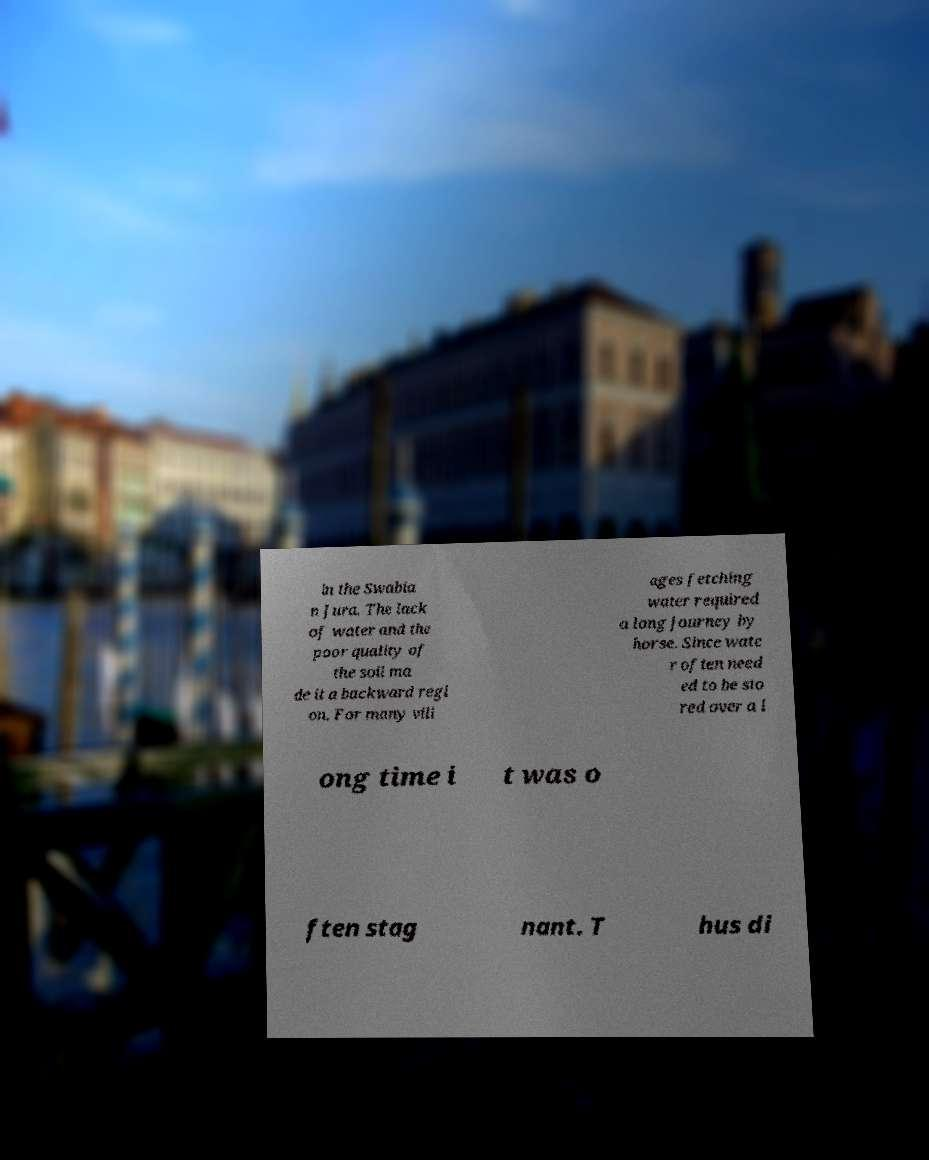Can you read and provide the text displayed in the image?This photo seems to have some interesting text. Can you extract and type it out for me? in the Swabia n Jura. The lack of water and the poor quality of the soil ma de it a backward regi on. For many vill ages fetching water required a long journey by horse. Since wate r often need ed to be sto red over a l ong time i t was o ften stag nant. T hus di 